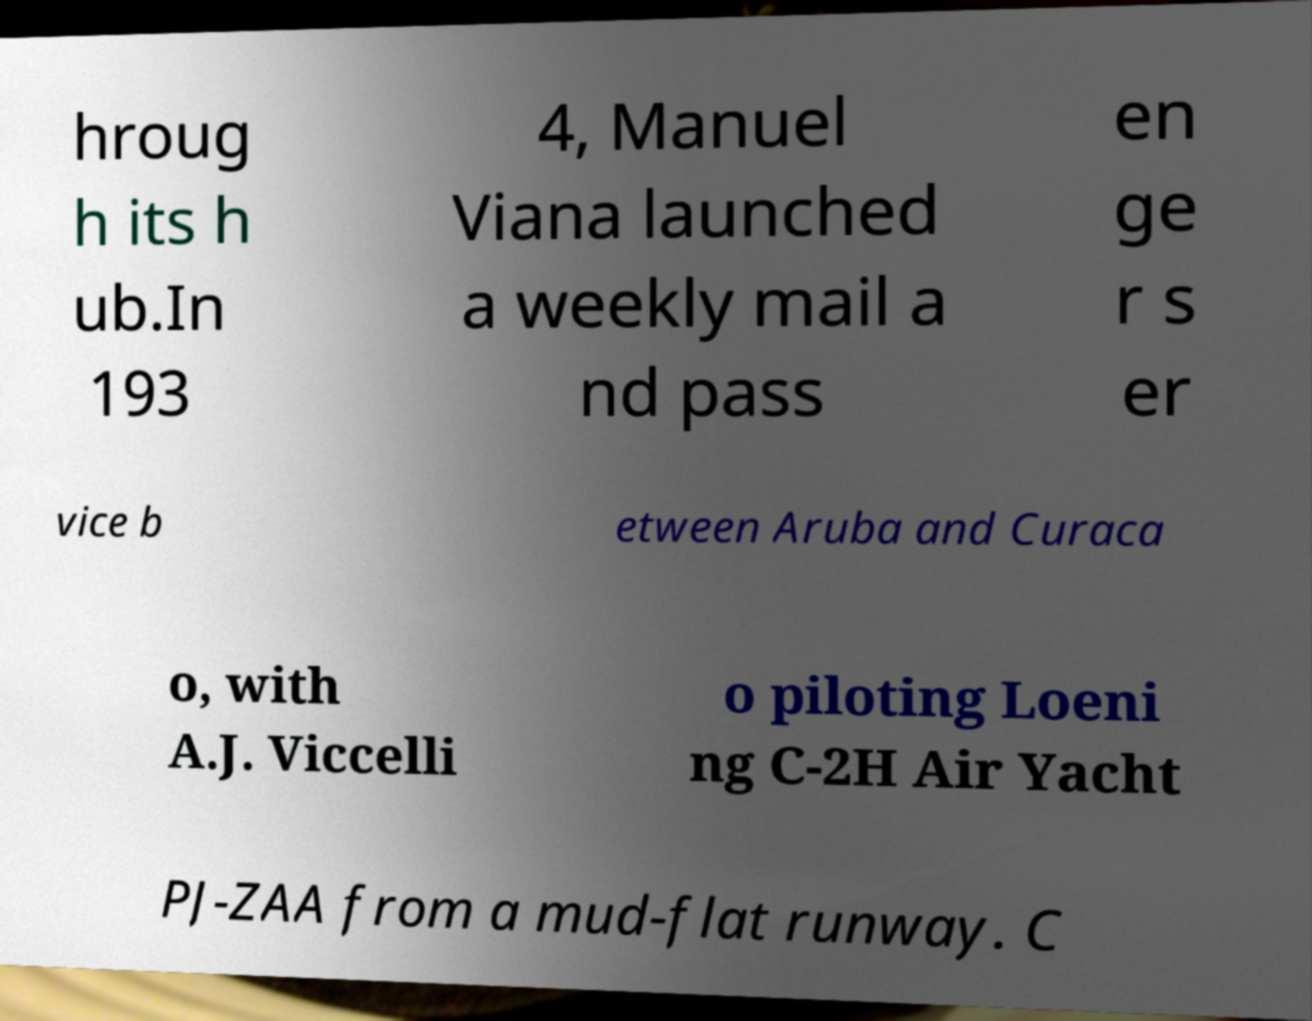Can you accurately transcribe the text from the provided image for me? hroug h its h ub.In 193 4, Manuel Viana launched a weekly mail a nd pass en ge r s er vice b etween Aruba and Curaca o, with A.J. Viccelli o piloting Loeni ng C-2H Air Yacht PJ-ZAA from a mud-flat runway. C 